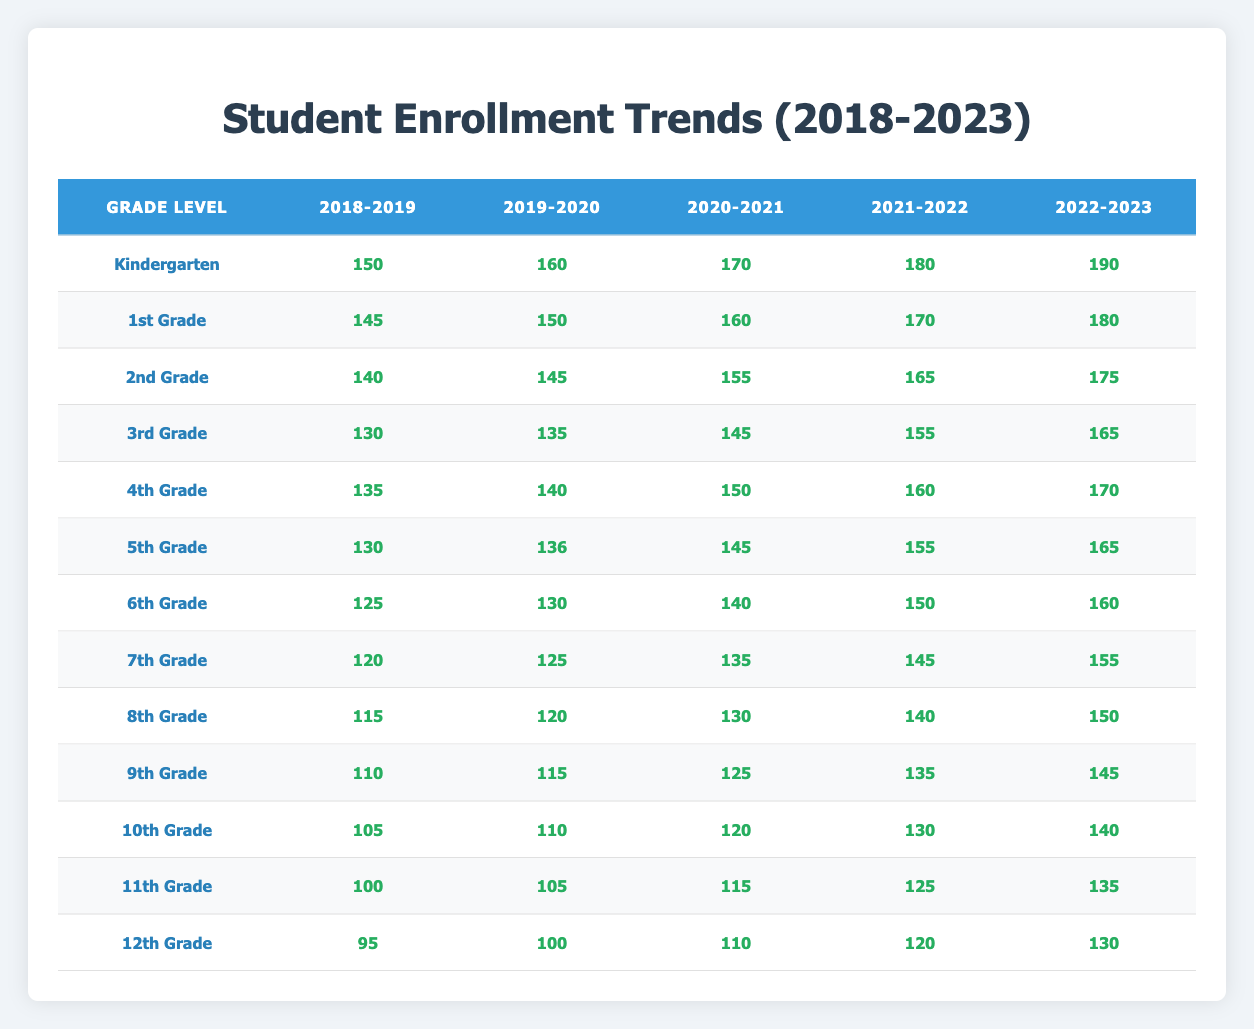What was the enrollment for Kindergarten in the academic year 2020-2021? Looking at the table under the Kindergarten row for the year 2020-2021, the enrollment value listed is 170.
Answer: 170 Which grade level had the highest enrollment in the academic year 2022-2023? In examining the last column for 2022-2023, Kindergarten shows the highest enrollment at 190 compared to other grades.
Answer: Kindergarten What is the difference in enrollment for 5th Grade between the academic years 2019-2020 and 2021-2022? For 5th Grade, the enrollment in 2019-2020 is 136 and in 2021-2022 it is 155. The difference can be calculated as 155 - 136 = 19.
Answer: 19 Did the enrollment for 12th Grade increase from the academic year 2021-2022 to 2022-2023? The enrollment in 2021-2022 was 120 and in 2022-2023 it was 130. Since 130 is greater than 120, we conclude that enrollment did increase.
Answer: Yes What is the total enrollment for 3rd Grade across all academic years from 2018-2023? The enrollment numbers for 3rd Grade for each year are: 130 (2018-2019), 135 (2019-2020), 145 (2020-2021), 155 (2021-2022), and 165 (2022-2023). Adding these values gives 130 + 135 + 145 + 155 + 165 = 730.
Answer: 730 Which grade level experienced the most significant enrollment growth from 2018-2019 to 2022-2023? For Kindergarten, enrollment rose from 150 to 190 (40 increase); for 1st Grade, from 145 to 180 (35 increase); for 2nd Grade, from 140 to 175 (35 increase); for 4th Grade, from 135 to 170 (35 increase); and for 3rd Grade, from 130 to 165 (35 increase). Kindergarten had the highest growth of 40.
Answer: Kindergarten Is it true that 11th Grade had more students enrolled in 2020-2021 compared to 2019-2020? Checking the enrollments, 11th Grade had 105 students in 2019-2020 and 115 in 2020-2021. Since 115 is greater than 105, it is true that enrollment increased.
Answer: Yes What was the average enrollment for 7th Grade across the years 2019-2020 to 2022-2023? The enrollments for 7th Grade are 125 (2019-2020), 135 (2020-2021), 145 (2021-2022), and 155 (2022-2023). The average is calculated as (125 + 135 + 145 + 155) / 4 = 140.
Answer: 140 